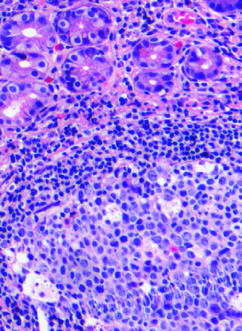re lymphoid aggregates with germinal centers and abundant subepi-thelial plasma cells within the superficial lamina propria characteristic of h. pylori gastritis?
Answer the question using a single word or phrase. Yes 